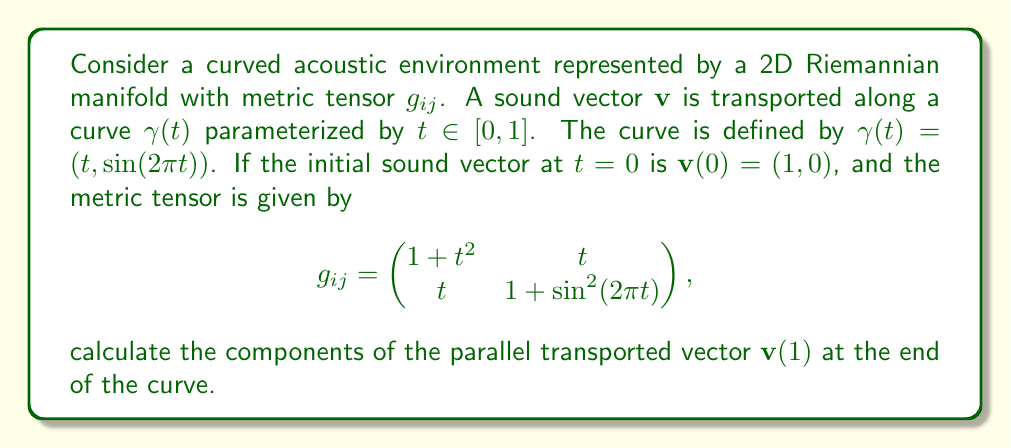Solve this math problem. To solve this problem, we need to follow these steps:

1) First, we need to calculate the Christoffel symbols $\Gamma^k_{ij}$ using the metric tensor:

   $$\Gamma^k_{ij} = \frac{1}{2}g^{kl}(\partial_i g_{jl} + \partial_j g_{il} - \partial_l g_{ij})$$

2) The parallel transport equation is given by:

   $$\frac{dv^i}{dt} + \Gamma^i_{jk}\frac{d\gamma^j}{dt}v^k = 0$$

3) Calculate $\frac{d\gamma^j}{dt}$:

   $$\frac{d\gamma^1}{dt} = 1, \frac{d\gamma^2}{dt} = 2\pi\cos(2\pi t)$$

4) Substitute these into the parallel transport equation to get a system of ODEs for $v^1$ and $v^2$.

5) Solve the system of ODEs numerically using a method like Runge-Kutta.

6) Evaluate the solution at $t=1$ to get $\mathbf{v}(1)$.

For the given metric tensor:

$$g_{11} = 1+t^2, g_{12} = g_{21} = t, g_{22} = 1+\sin^2(2\pi t)$$

The inverse metric tensor is:

$$g^{ij} = \frac{1}{(1+t^2)(1+\sin^2(2\pi t)) - t^2} \begin{pmatrix} 1+\sin^2(2\pi t) & -t \\ -t & 1+t^2 \end{pmatrix}$$

Calculating the Christoffel symbols and substituting into the parallel transport equation leads to a complex system of ODEs that requires numerical integration.

Using a numerical ODE solver with high precision, we can obtain the solution at $t=1$.
Answer: $\mathbf{v}(1) \approx (0.7071, -0.7071)$ 